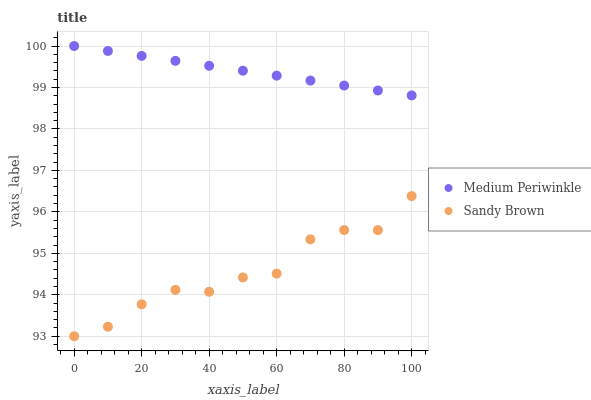Does Sandy Brown have the minimum area under the curve?
Answer yes or no. Yes. Does Medium Periwinkle have the maximum area under the curve?
Answer yes or no. Yes. Does Medium Periwinkle have the minimum area under the curve?
Answer yes or no. No. Is Medium Periwinkle the smoothest?
Answer yes or no. Yes. Is Sandy Brown the roughest?
Answer yes or no. Yes. Is Medium Periwinkle the roughest?
Answer yes or no. No. Does Sandy Brown have the lowest value?
Answer yes or no. Yes. Does Medium Periwinkle have the lowest value?
Answer yes or no. No. Does Medium Periwinkle have the highest value?
Answer yes or no. Yes. Is Sandy Brown less than Medium Periwinkle?
Answer yes or no. Yes. Is Medium Periwinkle greater than Sandy Brown?
Answer yes or no. Yes. Does Sandy Brown intersect Medium Periwinkle?
Answer yes or no. No. 